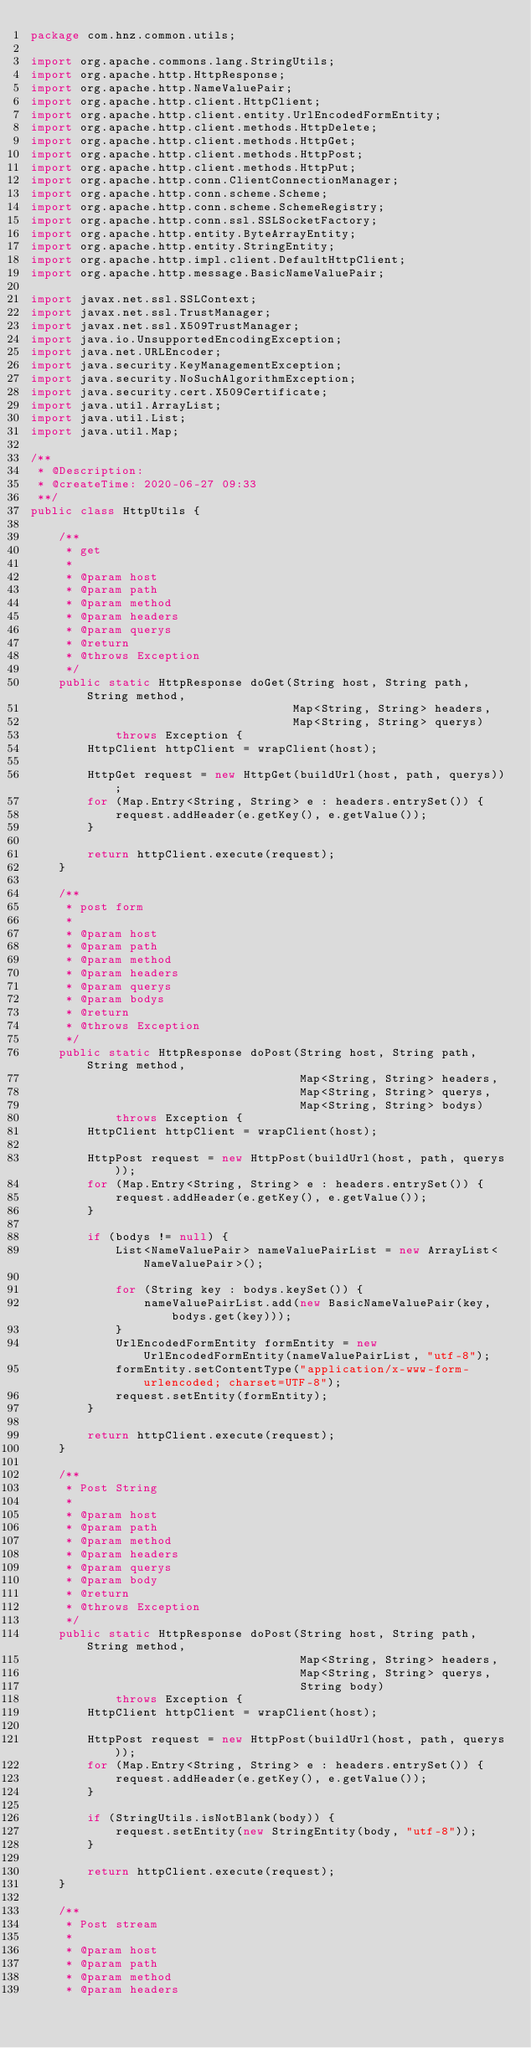Convert code to text. <code><loc_0><loc_0><loc_500><loc_500><_Java_>package com.hnz.common.utils;

import org.apache.commons.lang.StringUtils;
import org.apache.http.HttpResponse;
import org.apache.http.NameValuePair;
import org.apache.http.client.HttpClient;
import org.apache.http.client.entity.UrlEncodedFormEntity;
import org.apache.http.client.methods.HttpDelete;
import org.apache.http.client.methods.HttpGet;
import org.apache.http.client.methods.HttpPost;
import org.apache.http.client.methods.HttpPut;
import org.apache.http.conn.ClientConnectionManager;
import org.apache.http.conn.scheme.Scheme;
import org.apache.http.conn.scheme.SchemeRegistry;
import org.apache.http.conn.ssl.SSLSocketFactory;
import org.apache.http.entity.ByteArrayEntity;
import org.apache.http.entity.StringEntity;
import org.apache.http.impl.client.DefaultHttpClient;
import org.apache.http.message.BasicNameValuePair;

import javax.net.ssl.SSLContext;
import javax.net.ssl.TrustManager;
import javax.net.ssl.X509TrustManager;
import java.io.UnsupportedEncodingException;
import java.net.URLEncoder;
import java.security.KeyManagementException;
import java.security.NoSuchAlgorithmException;
import java.security.cert.X509Certificate;
import java.util.ArrayList;
import java.util.List;
import java.util.Map;

/**
 * @Description:
 * @createTime: 2020-06-27 09:33
 **/
public class HttpUtils {

    /**
     * get
     *
     * @param host
     * @param path
     * @param method
     * @param headers
     * @param querys
     * @return
     * @throws Exception
     */
    public static HttpResponse doGet(String host, String path, String method,
                                     Map<String, String> headers,
                                     Map<String, String> querys)
            throws Exception {
        HttpClient httpClient = wrapClient(host);

        HttpGet request = new HttpGet(buildUrl(host, path, querys));
        for (Map.Entry<String, String> e : headers.entrySet()) {
            request.addHeader(e.getKey(), e.getValue());
        }

        return httpClient.execute(request);
    }

    /**
     * post form
     *
     * @param host
     * @param path
     * @param method
     * @param headers
     * @param querys
     * @param bodys
     * @return
     * @throws Exception
     */
    public static HttpResponse doPost(String host, String path, String method,
                                      Map<String, String> headers,
                                      Map<String, String> querys,
                                      Map<String, String> bodys)
            throws Exception {
        HttpClient httpClient = wrapClient(host);

        HttpPost request = new HttpPost(buildUrl(host, path, querys));
        for (Map.Entry<String, String> e : headers.entrySet()) {
            request.addHeader(e.getKey(), e.getValue());
        }

        if (bodys != null) {
            List<NameValuePair> nameValuePairList = new ArrayList<NameValuePair>();

            for (String key : bodys.keySet()) {
                nameValuePairList.add(new BasicNameValuePair(key, bodys.get(key)));
            }
            UrlEncodedFormEntity formEntity = new UrlEncodedFormEntity(nameValuePairList, "utf-8");
            formEntity.setContentType("application/x-www-form-urlencoded; charset=UTF-8");
            request.setEntity(formEntity);
        }

        return httpClient.execute(request);
    }

    /**
     * Post String
     *
     * @param host
     * @param path
     * @param method
     * @param headers
     * @param querys
     * @param body
     * @return
     * @throws Exception
     */
    public static HttpResponse doPost(String host, String path, String method,
                                      Map<String, String> headers,
                                      Map<String, String> querys,
                                      String body)
            throws Exception {
        HttpClient httpClient = wrapClient(host);

        HttpPost request = new HttpPost(buildUrl(host, path, querys));
        for (Map.Entry<String, String> e : headers.entrySet()) {
            request.addHeader(e.getKey(), e.getValue());
        }

        if (StringUtils.isNotBlank(body)) {
            request.setEntity(new StringEntity(body, "utf-8"));
        }

        return httpClient.execute(request);
    }

    /**
     * Post stream
     *
     * @param host
     * @param path
     * @param method
     * @param headers</code> 